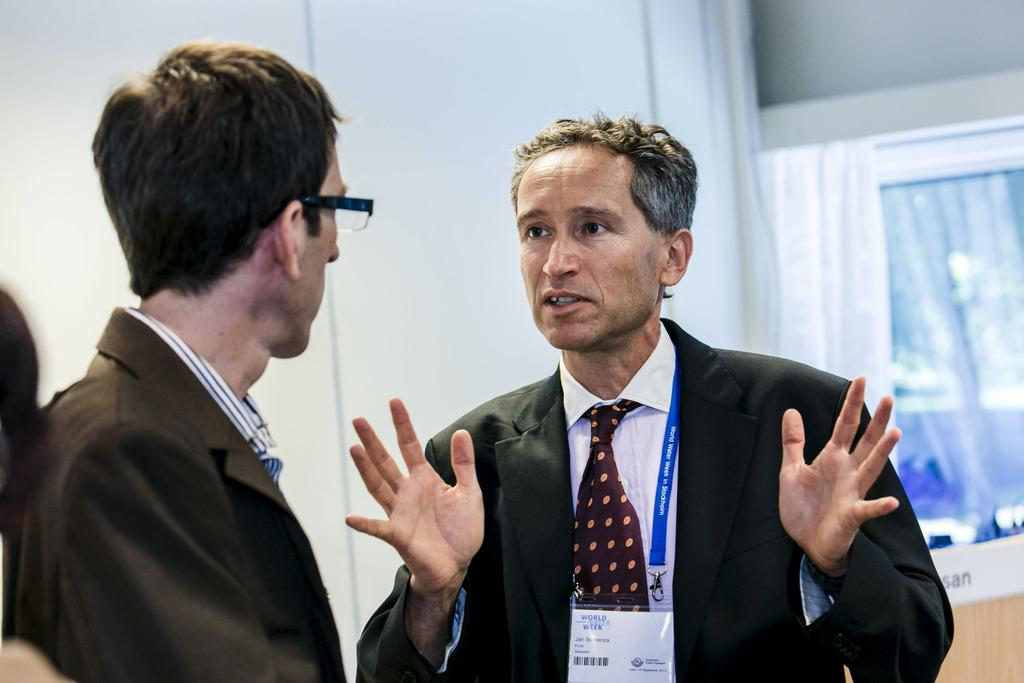What is the position of the person on the right side of the image? There is a person standing on the right side of the image. What can be seen on the person on the right side? The person on the right side is wearing an ID card. Can you describe the person on the left side of the image? There is another person standing on the left side of the image. What is visible in the background of the image? There is a wall in the background of the image. What type of acoustics can be heard in the image? There is no information about the acoustics in the image, as it only shows two people standing and a wall in the background. Is there an actor present in the image? There is no mention of an actor in the image, only two people standing. 